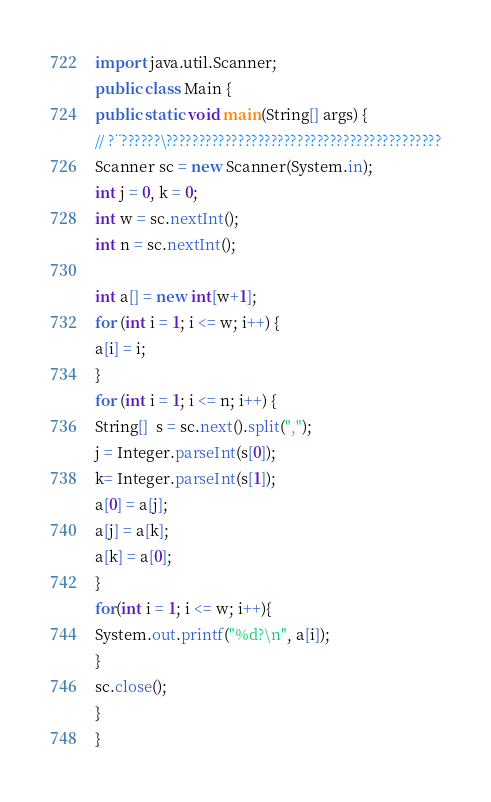Convert code to text. <code><loc_0><loc_0><loc_500><loc_500><_Java_>import java.util.Scanner;
public class Main {
public static void main(String[] args) {
// ?¨??????\??????????????????????????????????????????
Scanner sc = new Scanner(System.in); 
int j = 0, k = 0;
int w = sc.nextInt();
int n = sc.nextInt();

int a[] = new int[w+1];
for (int i = 1; i <= w; i++) { 
a[i] = i;
}
for (int i = 1; i <= n; i++) {
String[]  s = sc.next().split(",");
j = Integer.parseInt(s[0]);
k= Integer.parseInt(s[1]);
a[0] = a[j];
a[j] = a[k];
a[k] = a[0];
}
for(int i = 1; i <= w; i++){
System.out.printf("%d?\n", a[i]);
}
sc.close();
}
}</code> 